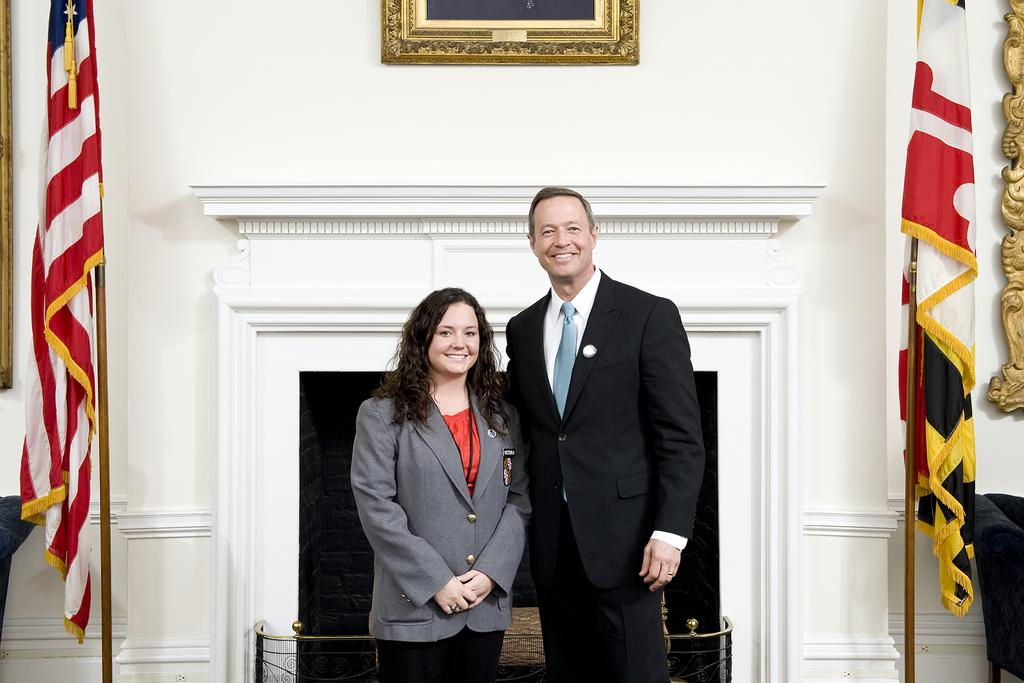How many people are in the image? There are two people in the image, a woman and a man. What are the people wearing in the image? Both the woman and the man are wearing blazers. What are the people doing in the image? The woman and the man are standing and smiling. What can be seen in the background of the image? There is a wall, a frame attached to the wall, two flags, and a fireplace in the background. What type of face patch can be seen on the woman's face in the image? There is no face patch present on the woman's face in the image. What is located on the top of the fireplace in the background? The provided facts do not mention any specific items on top of the fireplace, so it cannot be determined from the image. 